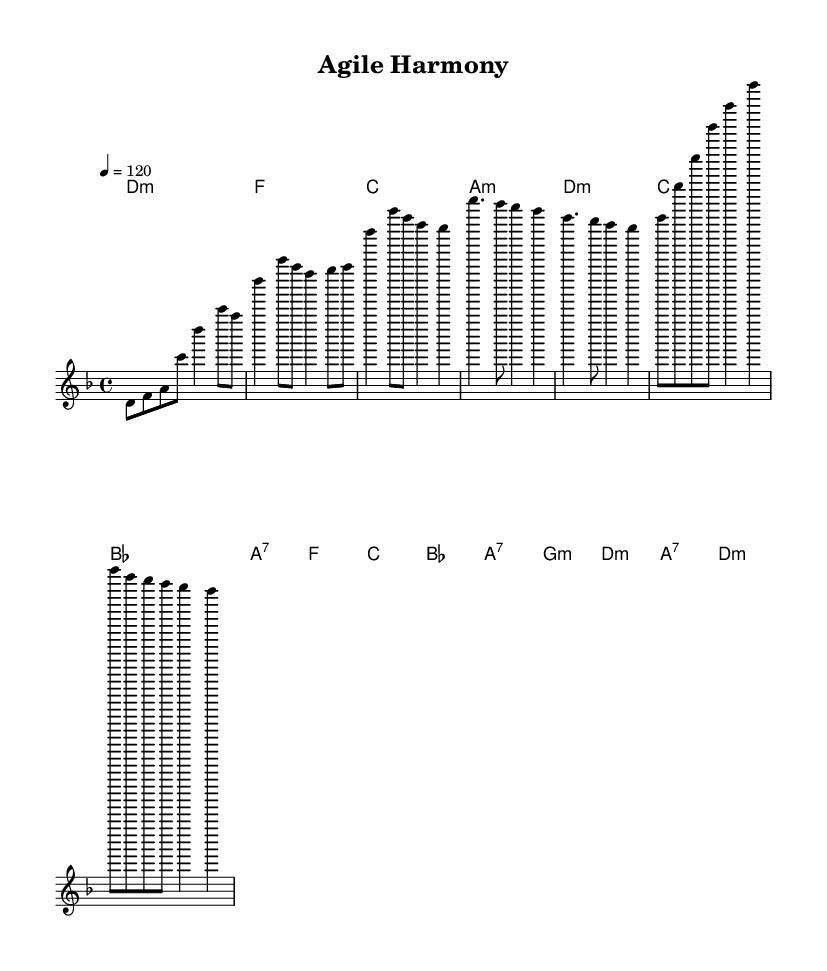What is the key signature of this music? The key signature is D minor, which has one flat.
Answer: D minor What is the time signature of the piece? The time signature is indicated as 4/4, which means there are four beats per measure and the quarter note gets one beat.
Answer: 4/4 What is the tempo marking for this music? The tempo marking indicates the speed of the piece is 120 beats per minute, suggesting a moderate pace.
Answer: 120 What chords are used in the chorus section? The chorus section uses the chords F major, C major, B flat major, and A7.
Answer: F, C, B flat, A7 How many measures are in the bridge section? The bridge section consists of four measures, each containing a combination of notes and rests.
Answer: 4 Which mode is predominantly used in this composition? The piece predominantly uses a minor mode, reflecting a somber and introspective character.
Answer: Minor What type of fusion is represented by this piece? This piece represents a fusion of electronic and world music elements, reflecting global collaboration and cross-cultural teamwork.
Answer: Electronic-world fusion 